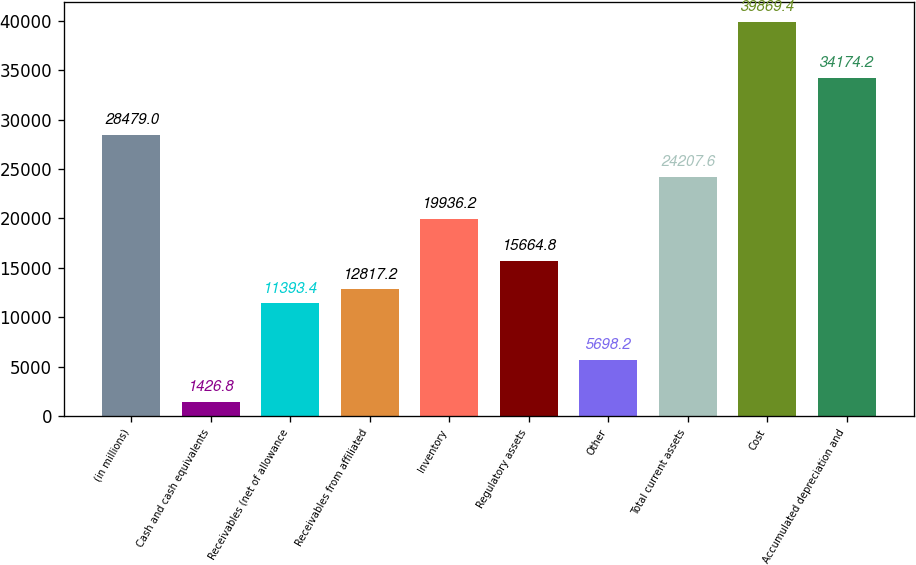Convert chart to OTSL. <chart><loc_0><loc_0><loc_500><loc_500><bar_chart><fcel>(in millions)<fcel>Cash and cash equivalents<fcel>Receivables (net of allowance<fcel>Receivables from affiliated<fcel>Inventory<fcel>Regulatory assets<fcel>Other<fcel>Total current assets<fcel>Cost<fcel>Accumulated depreciation and<nl><fcel>28479<fcel>1426.8<fcel>11393.4<fcel>12817.2<fcel>19936.2<fcel>15664.8<fcel>5698.2<fcel>24207.6<fcel>39869.4<fcel>34174.2<nl></chart> 